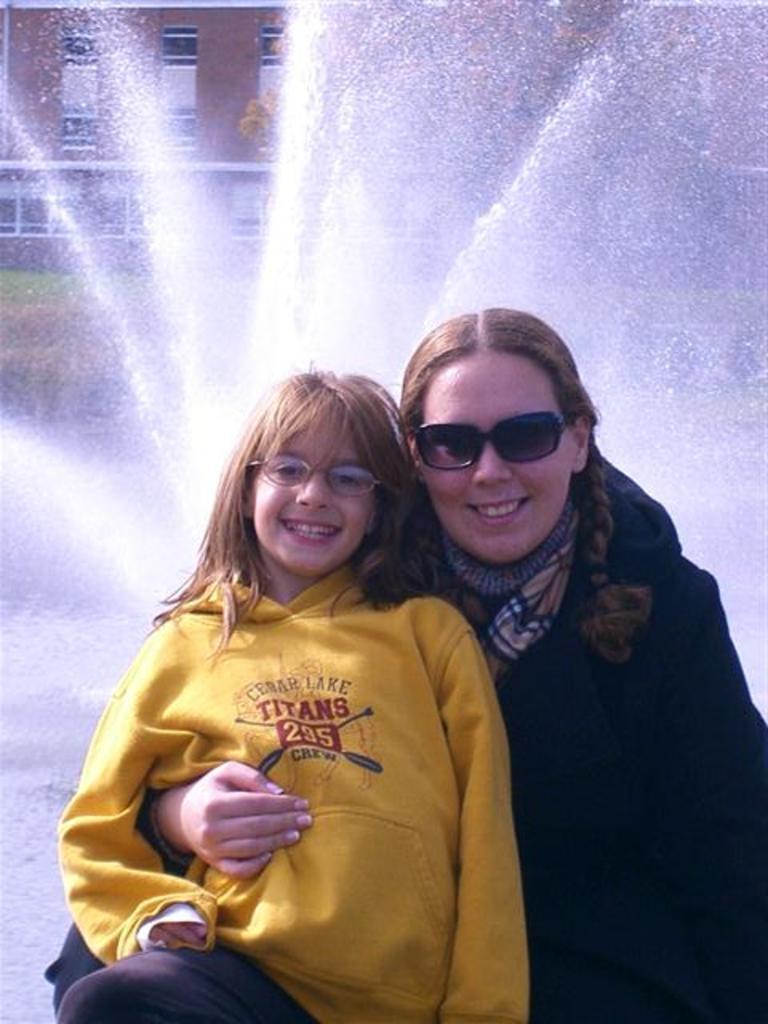Could you give a brief overview of what you see in this image? In this picture I can see a girl and a woman smiling, there is water fountain, and in the background there is a building. 